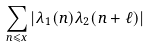Convert formula to latex. <formula><loc_0><loc_0><loc_500><loc_500>\sum _ { n \leqslant x } | \lambda _ { 1 } ( n ) \lambda _ { 2 } ( n + \ell ) |</formula> 